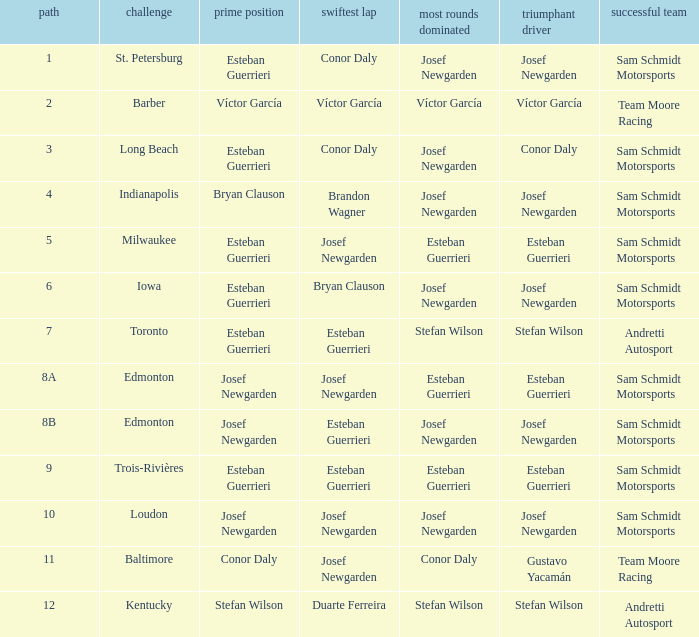What race did josef newgarden have the fastest lap and lead the most laps? Loudon. 